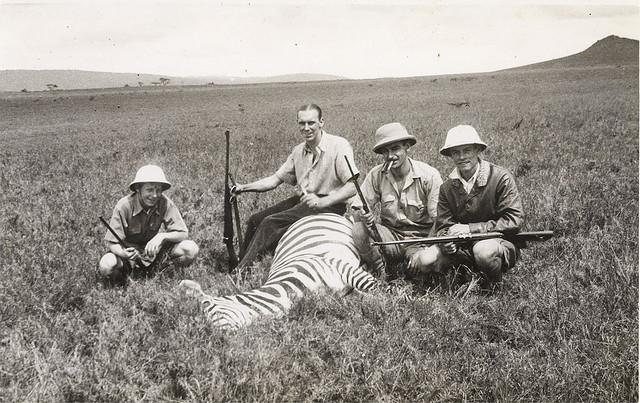Is this a modern photo?
Give a very brief answer. No. Are the hunters proud of their skill?
Keep it brief. Yes. What animal was hunted in this photo?
Quick response, please. Zebra. 